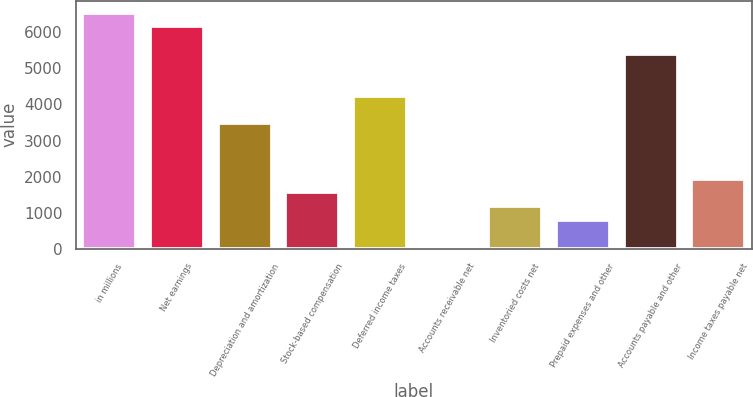Convert chart to OTSL. <chart><loc_0><loc_0><loc_500><loc_500><bar_chart><fcel>in millions<fcel>Net earnings<fcel>Depreciation and amortization<fcel>Stock-based compensation<fcel>Deferred income taxes<fcel>Accounts receivable net<fcel>Inventoried costs net<fcel>Prepaid expenses and other<fcel>Accounts payable and other<fcel>Income taxes payable net<nl><fcel>6546.1<fcel>6162.8<fcel>3479.7<fcel>1563.2<fcel>4246.3<fcel>30<fcel>1179.9<fcel>796.6<fcel>5396.2<fcel>1946.5<nl></chart> 